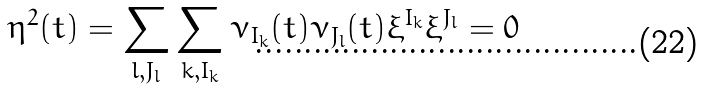<formula> <loc_0><loc_0><loc_500><loc_500>\eta ^ { 2 } ( t ) = \sum _ { l , J _ { l } } \sum _ { k , I _ { k } } \nu _ { I _ { k } } ( t ) \nu _ { J _ { l } } ( t ) \xi ^ { I _ { k } } \xi ^ { J _ { l } } = 0</formula> 